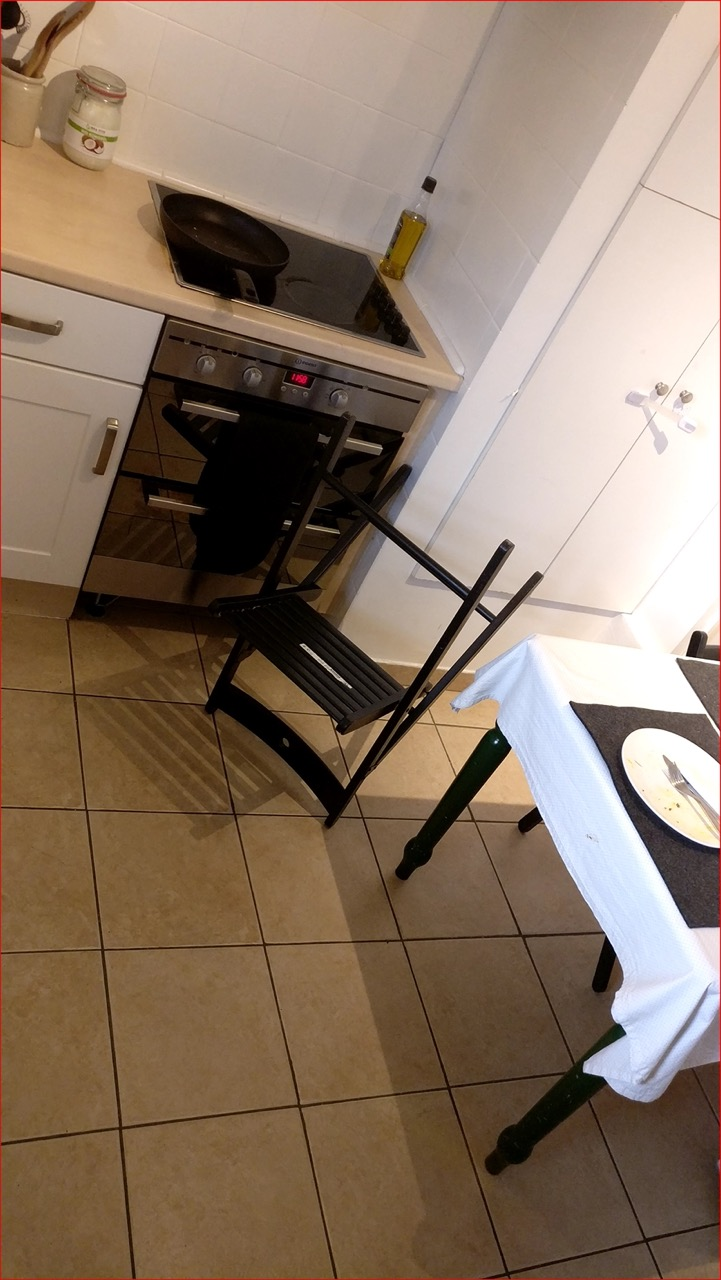What cooking items can be seen in the image? The image shows a stove with a black frying pan on top, beside the stove there is a bottle of cooking oil, suggesting some recent or upcoming cooking activity. 